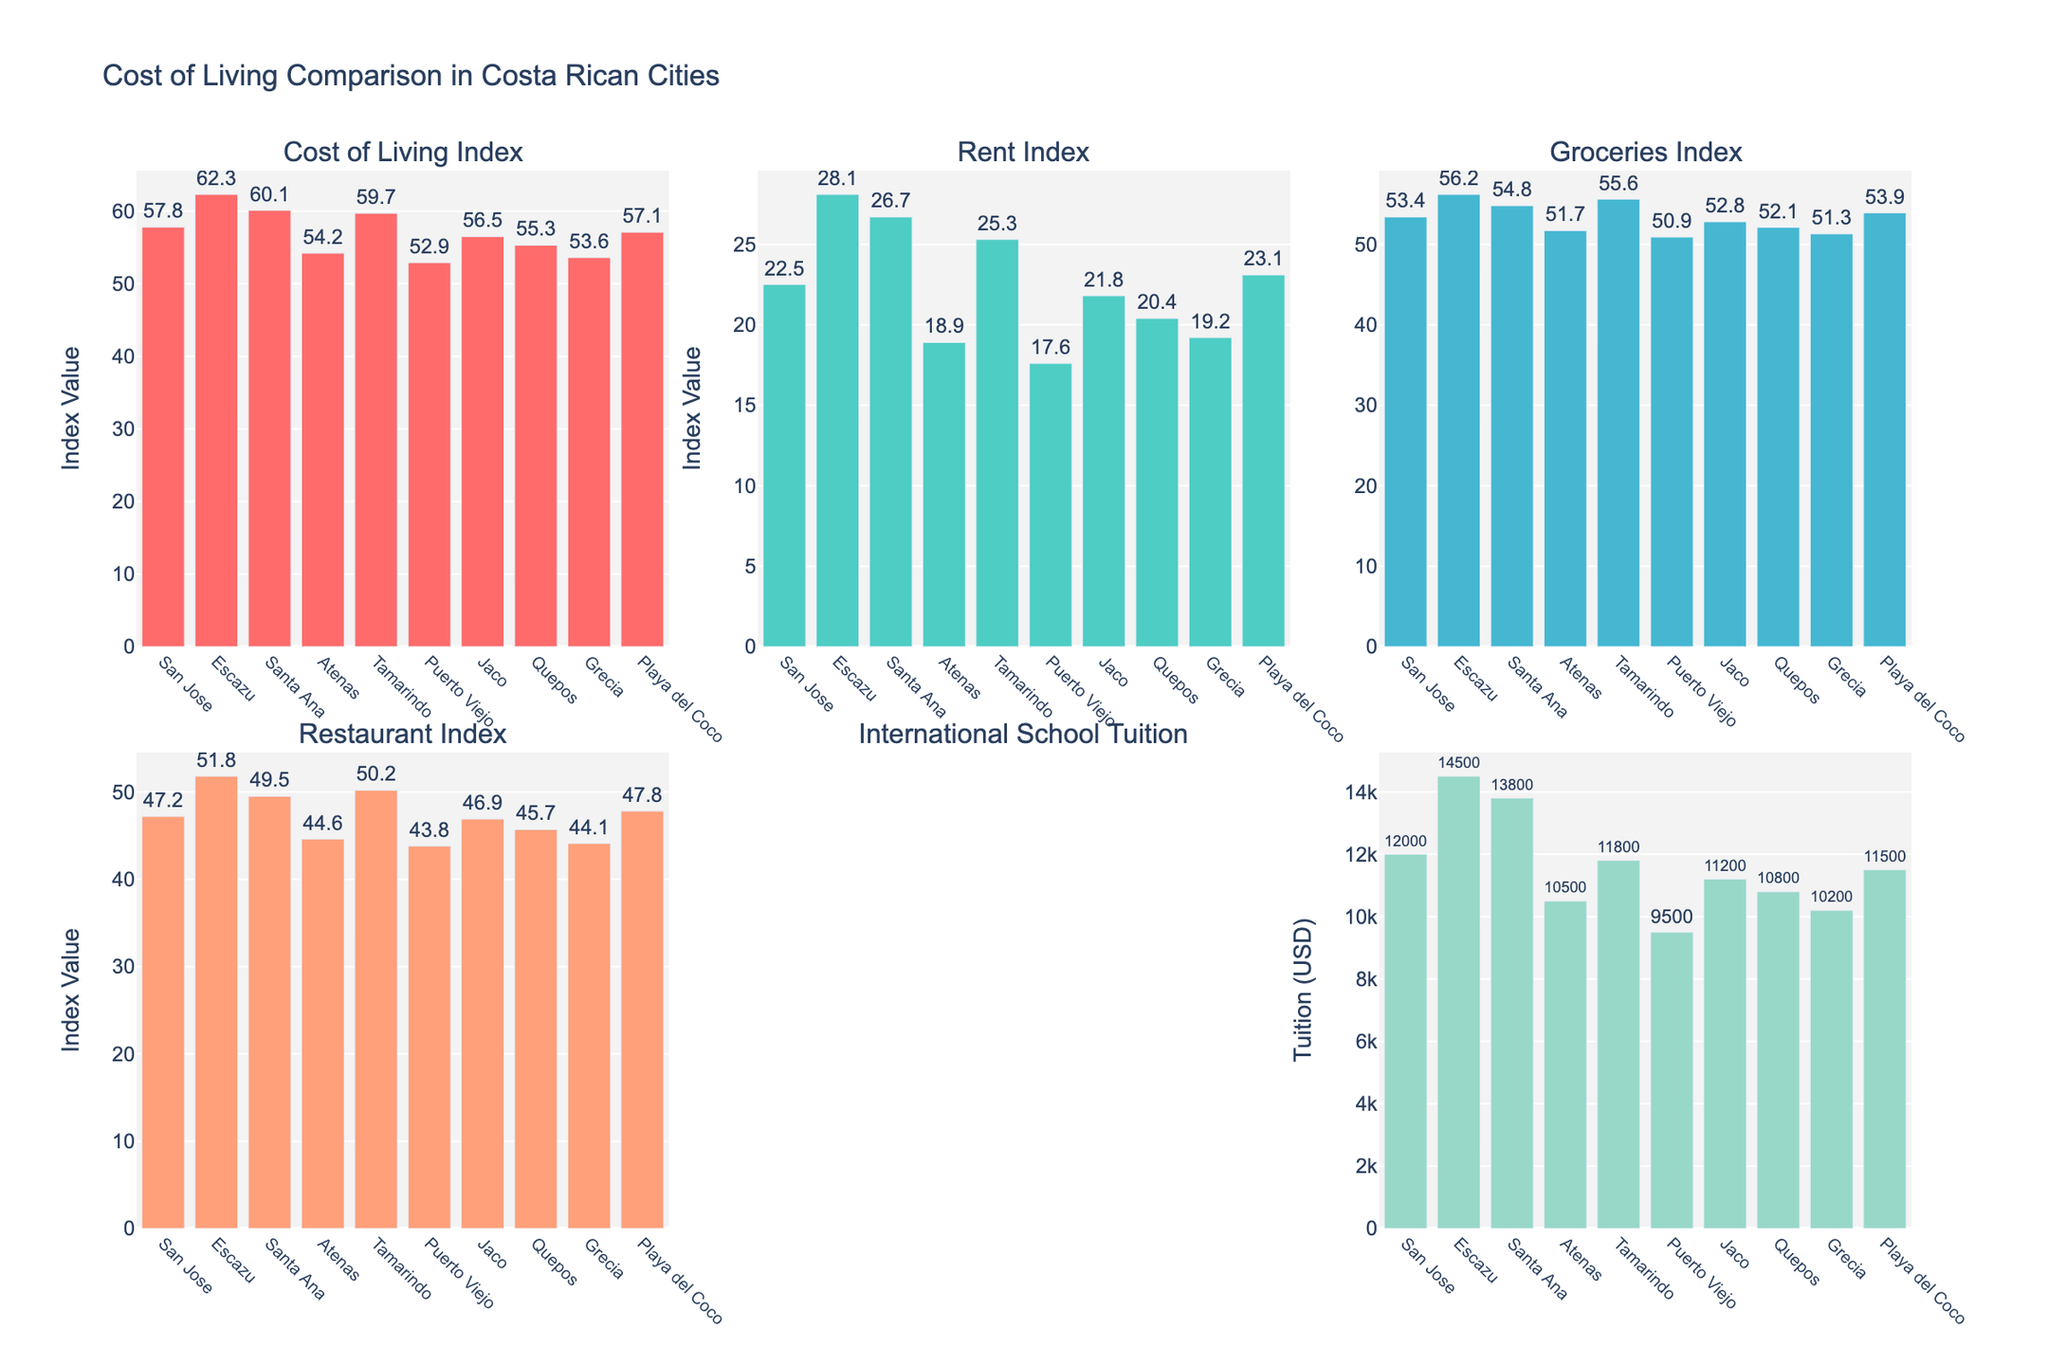What is the title of the figure? The title is usually placed at the top center of the plot. Based on the description, the title is "Cost of Living Comparison in Costa Rican Cities."
Answer: Cost of Living Comparison in Costa Rican Cities Which city has the highest Rent Index? By checking the subplots for the Rent Index, identify the bar with the highest value. Escazu has the highest Rent Index.
Answer: Escazu How does the International School Tuition in Santa Ana compare to that in Atenas? Look at the subplot for International School Tuition, find the values for Santa Ana and Atenas, and compare them. Santa Ana's tuition is $13,800, while Atenas's is $10,500. So, Santa Ana's tuition is higher by $3,300.
Answer: Santa Ana's tuition is $3,300 higher Which cities have a Groceries Index less than 52? Check the Groceries Index subplot, identify bars with values less than 52, and list those cities. Puerto Viejo (50.9) and Grecia (51.3) meet this criterion.
Answer: Puerto Viejo, Grecia What is the average Cost of Living Index for Escazu, Santa Ana, and Tamarindo? Find the Cost of Living Index for each of the three cities: Escazu (62.3), Santa Ana (60.1), and Tamarindo (59.7). Calculate their average: (62.3 + 60.1 + 59.7) / 3 = 60.7.
Answer: 60.7 Between Jaco and Quepos, which city has a higher Restaurant Index and by how much? Identify the Restaurant Index for Jaco (46.9) and Quepos (45.7). Subtract the smaller value from the larger one: 46.9 - 45.7 = 1.2.
Answer: Jaco by 1.2 If you were considering schools, would Grecia be a more economical choice for International School Tuition compared to Escazu? Compare the International School Tuition for Grecia ($10,200) and Escazu ($14,500). Grecia's tuition is more economical by $4,300.
Answer: Yes, Grecia is $4,300 more economical Which city has the lowest Cost of Living Index? Look at the Cost of Living Index subplot and find the city with the lowest bar. Puerto Viejo has the lowest Cost of Living Index (52.9).
Answer: Puerto Viejo Is the Groceries Index for Playa del Coco higher or lower than the average Groceries Index of all cities? First, calculate the average Groceries Index: (53.4 + 56.2 + 54.8 + 51.7 + 55.6 + 50.9 + 52.8 + 52.1 + 51.3 + 53.9) / 10 = 53.27. Compare it with Playa del Coco's value (53.9). Playa del Coco has a higher Groceries Index compared to the average.
Answer: Higher 